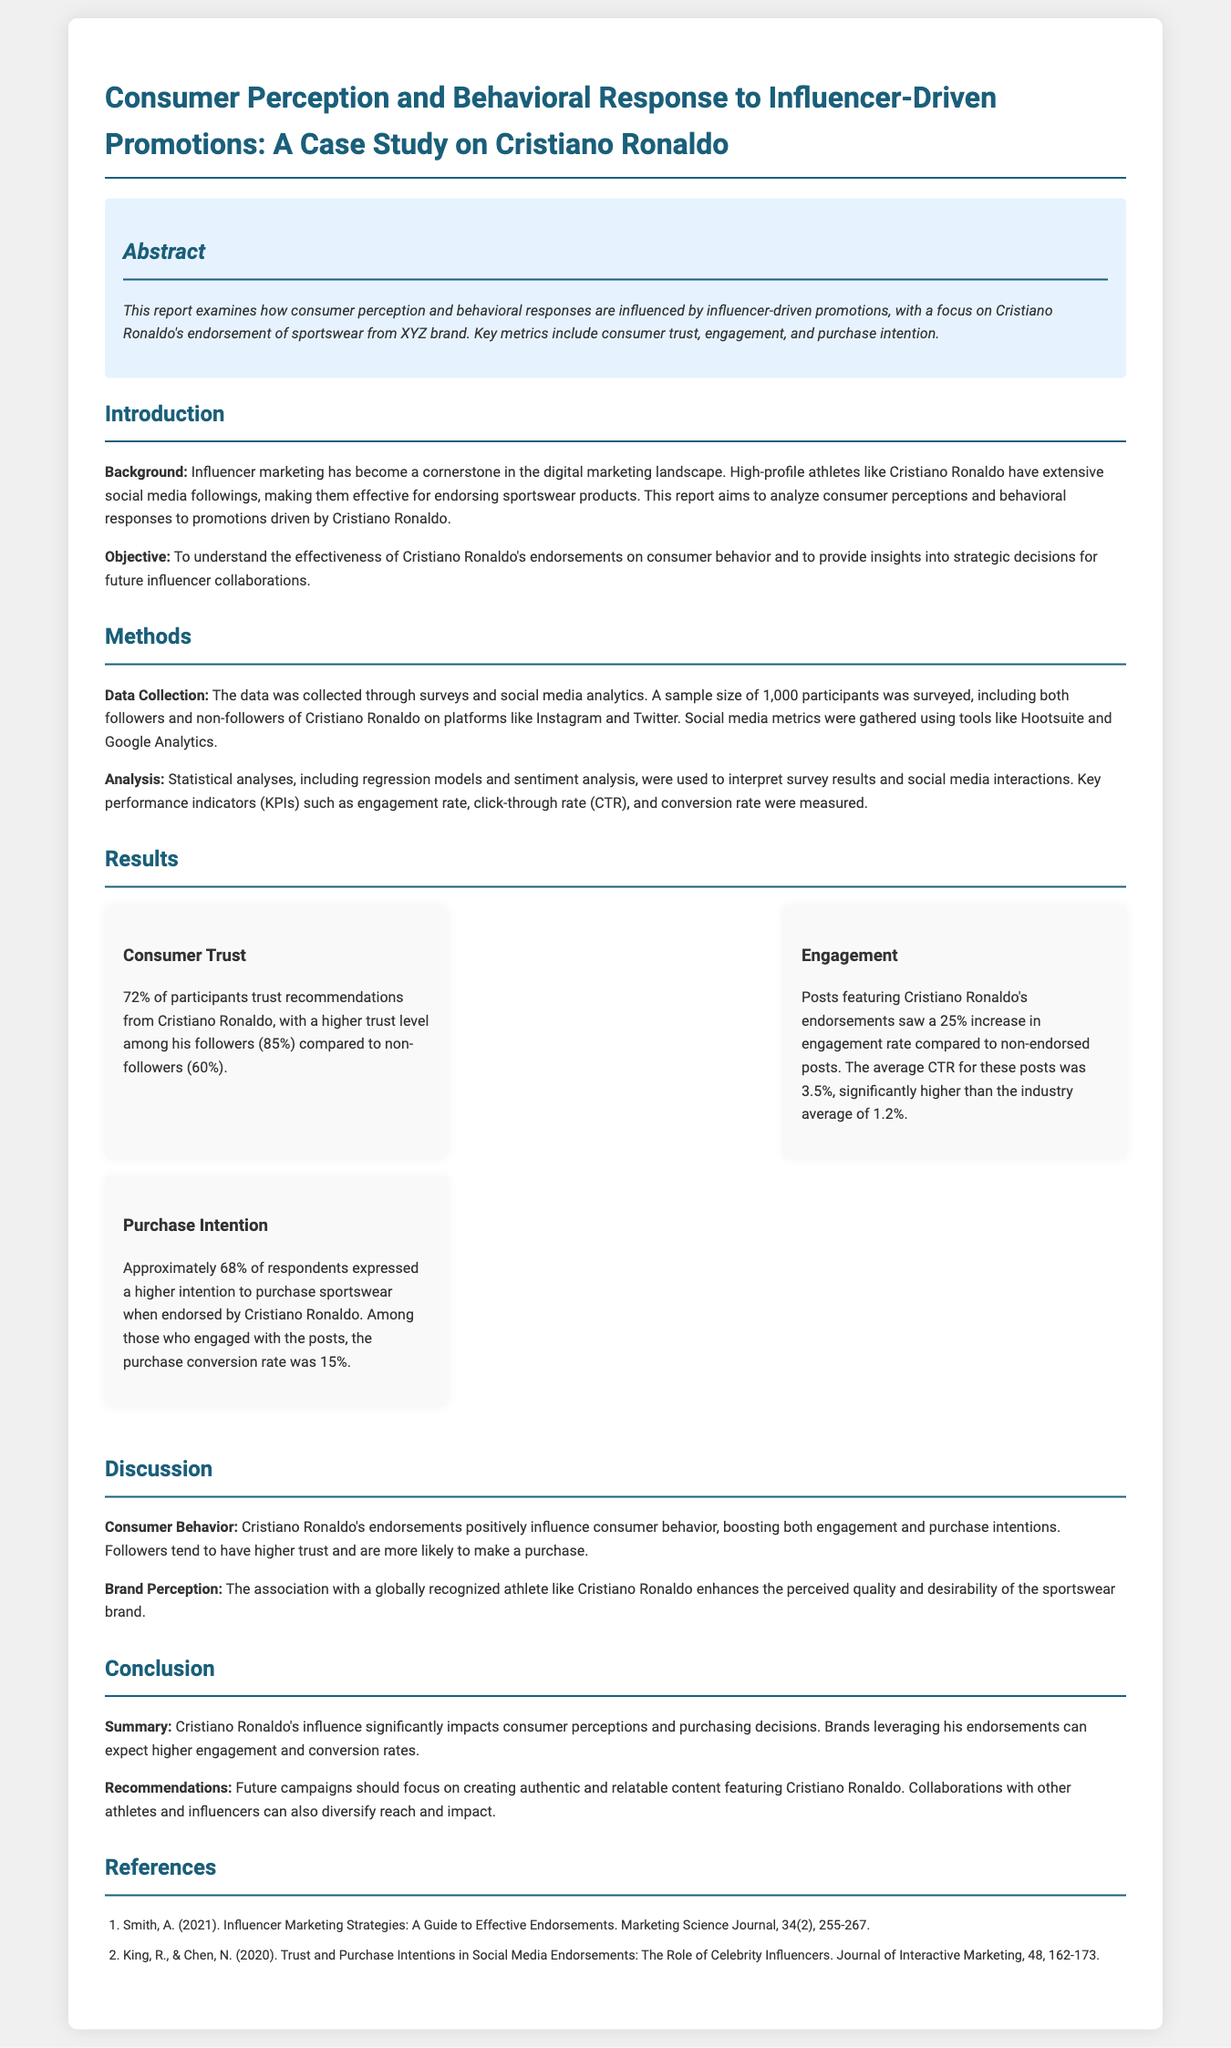what is the sample size of participants? The sample size of participants surveyed in the study was 1,000.
Answer: 1,000 what percentage of participants trust Cristiano Ronaldo's recommendations? The document states that 72% of participants trust recommendations from Cristiano Ronaldo.
Answer: 72% what is the average click-through rate (CTR) for posts featuring Cristiano Ronaldo's endorsements? The average CTR for these posts is mentioned as 3.5%.
Answer: 3.5% what influence does Cristiano Ronaldo's endorsement have on purchase intention? Approximately 68% of respondents expressed a higher intention to purchase sportswear when endorsed by Cristiano Ronaldo.
Answer: 68% which platform metrics were used for data collection? The tools mentioned for social media metrics gathering include Hootsuite and Google Analytics.
Answer: Hootsuite and Google Analytics how much higher is the engagement rate for posts endorsed by Cristiano Ronaldo compared to non-endorsed posts? The increase in engagement rate for endorsed posts compared to non-endorsed posts is 25%.
Answer: 25% what recommendation does the report make for future campaigns? The report recommends focusing on creating authentic and relatable content featuring Cristiano Ronaldo.
Answer: Authentic and relatable content what is the primary objective of the report? The primary objective of the report is to understand the effectiveness of Cristiano Ronaldo's endorsements on consumer behavior.
Answer: Effectiveness of endorsements on consumer behavior 